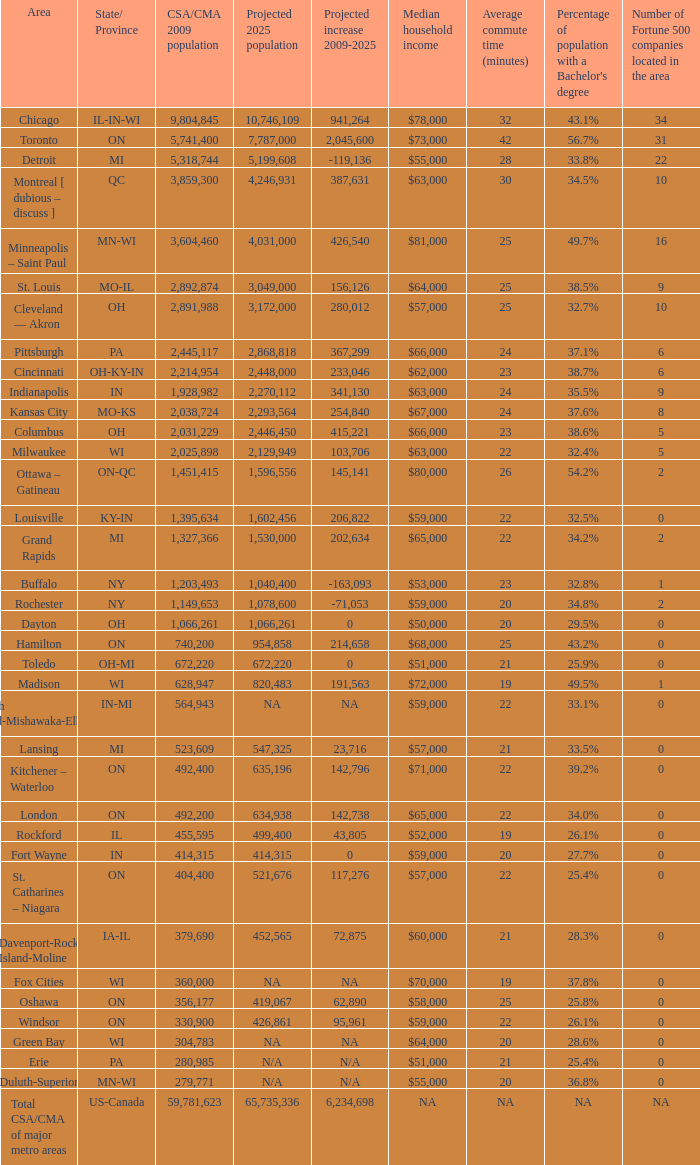What's the projected population of IN-MI? NA. 